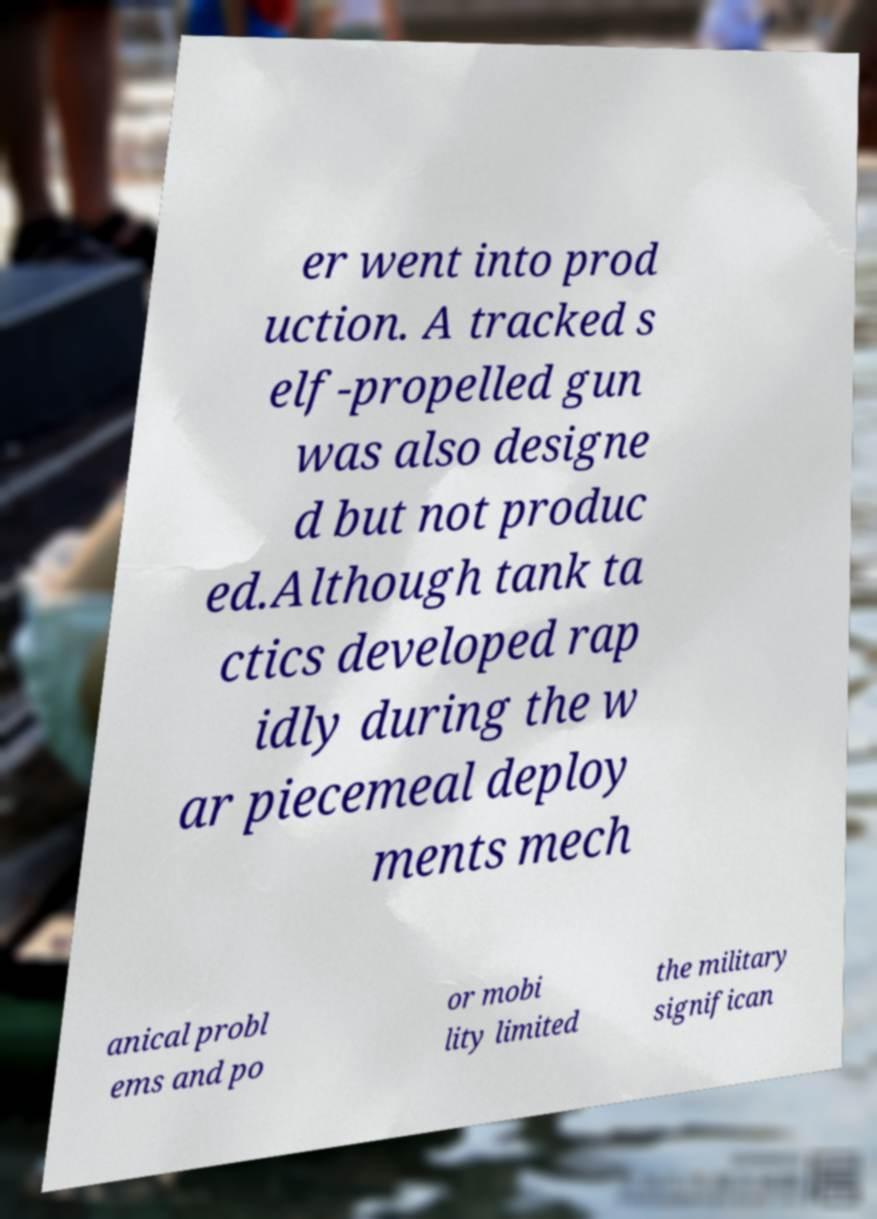Can you accurately transcribe the text from the provided image for me? er went into prod uction. A tracked s elf-propelled gun was also designe d but not produc ed.Although tank ta ctics developed rap idly during the w ar piecemeal deploy ments mech anical probl ems and po or mobi lity limited the military significan 